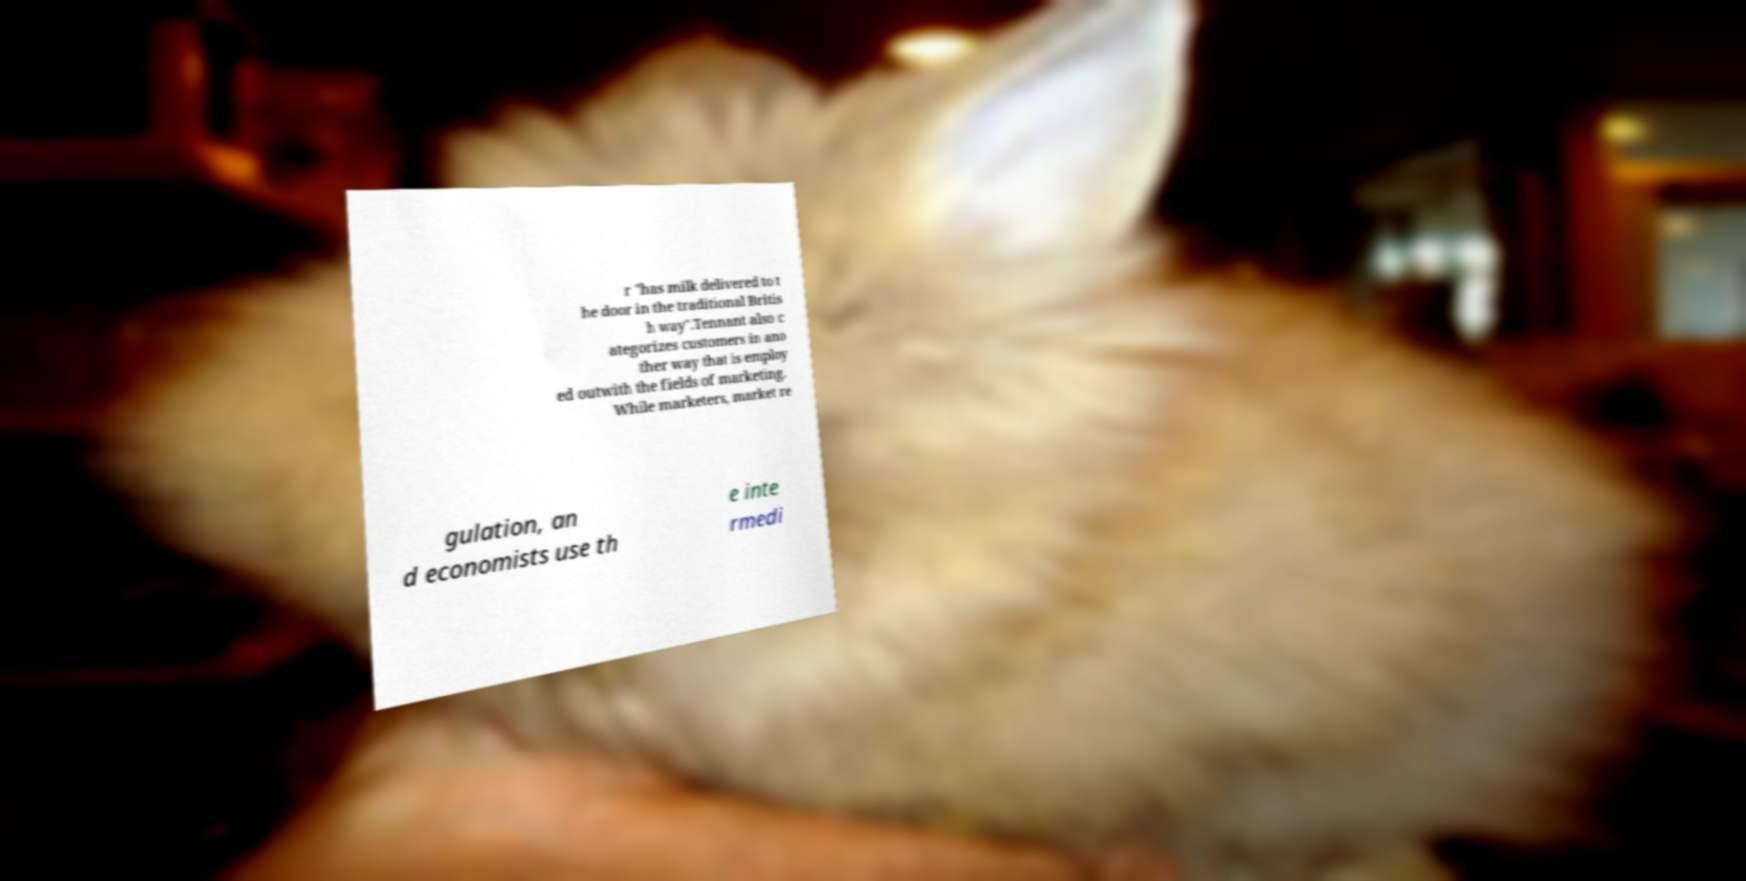Please identify and transcribe the text found in this image. r "has milk delivered to t he door in the traditional Britis h way".Tennant also c ategorizes customers in ano ther way that is employ ed outwith the fields of marketing. While marketers, market re gulation, an d economists use th e inte rmedi 